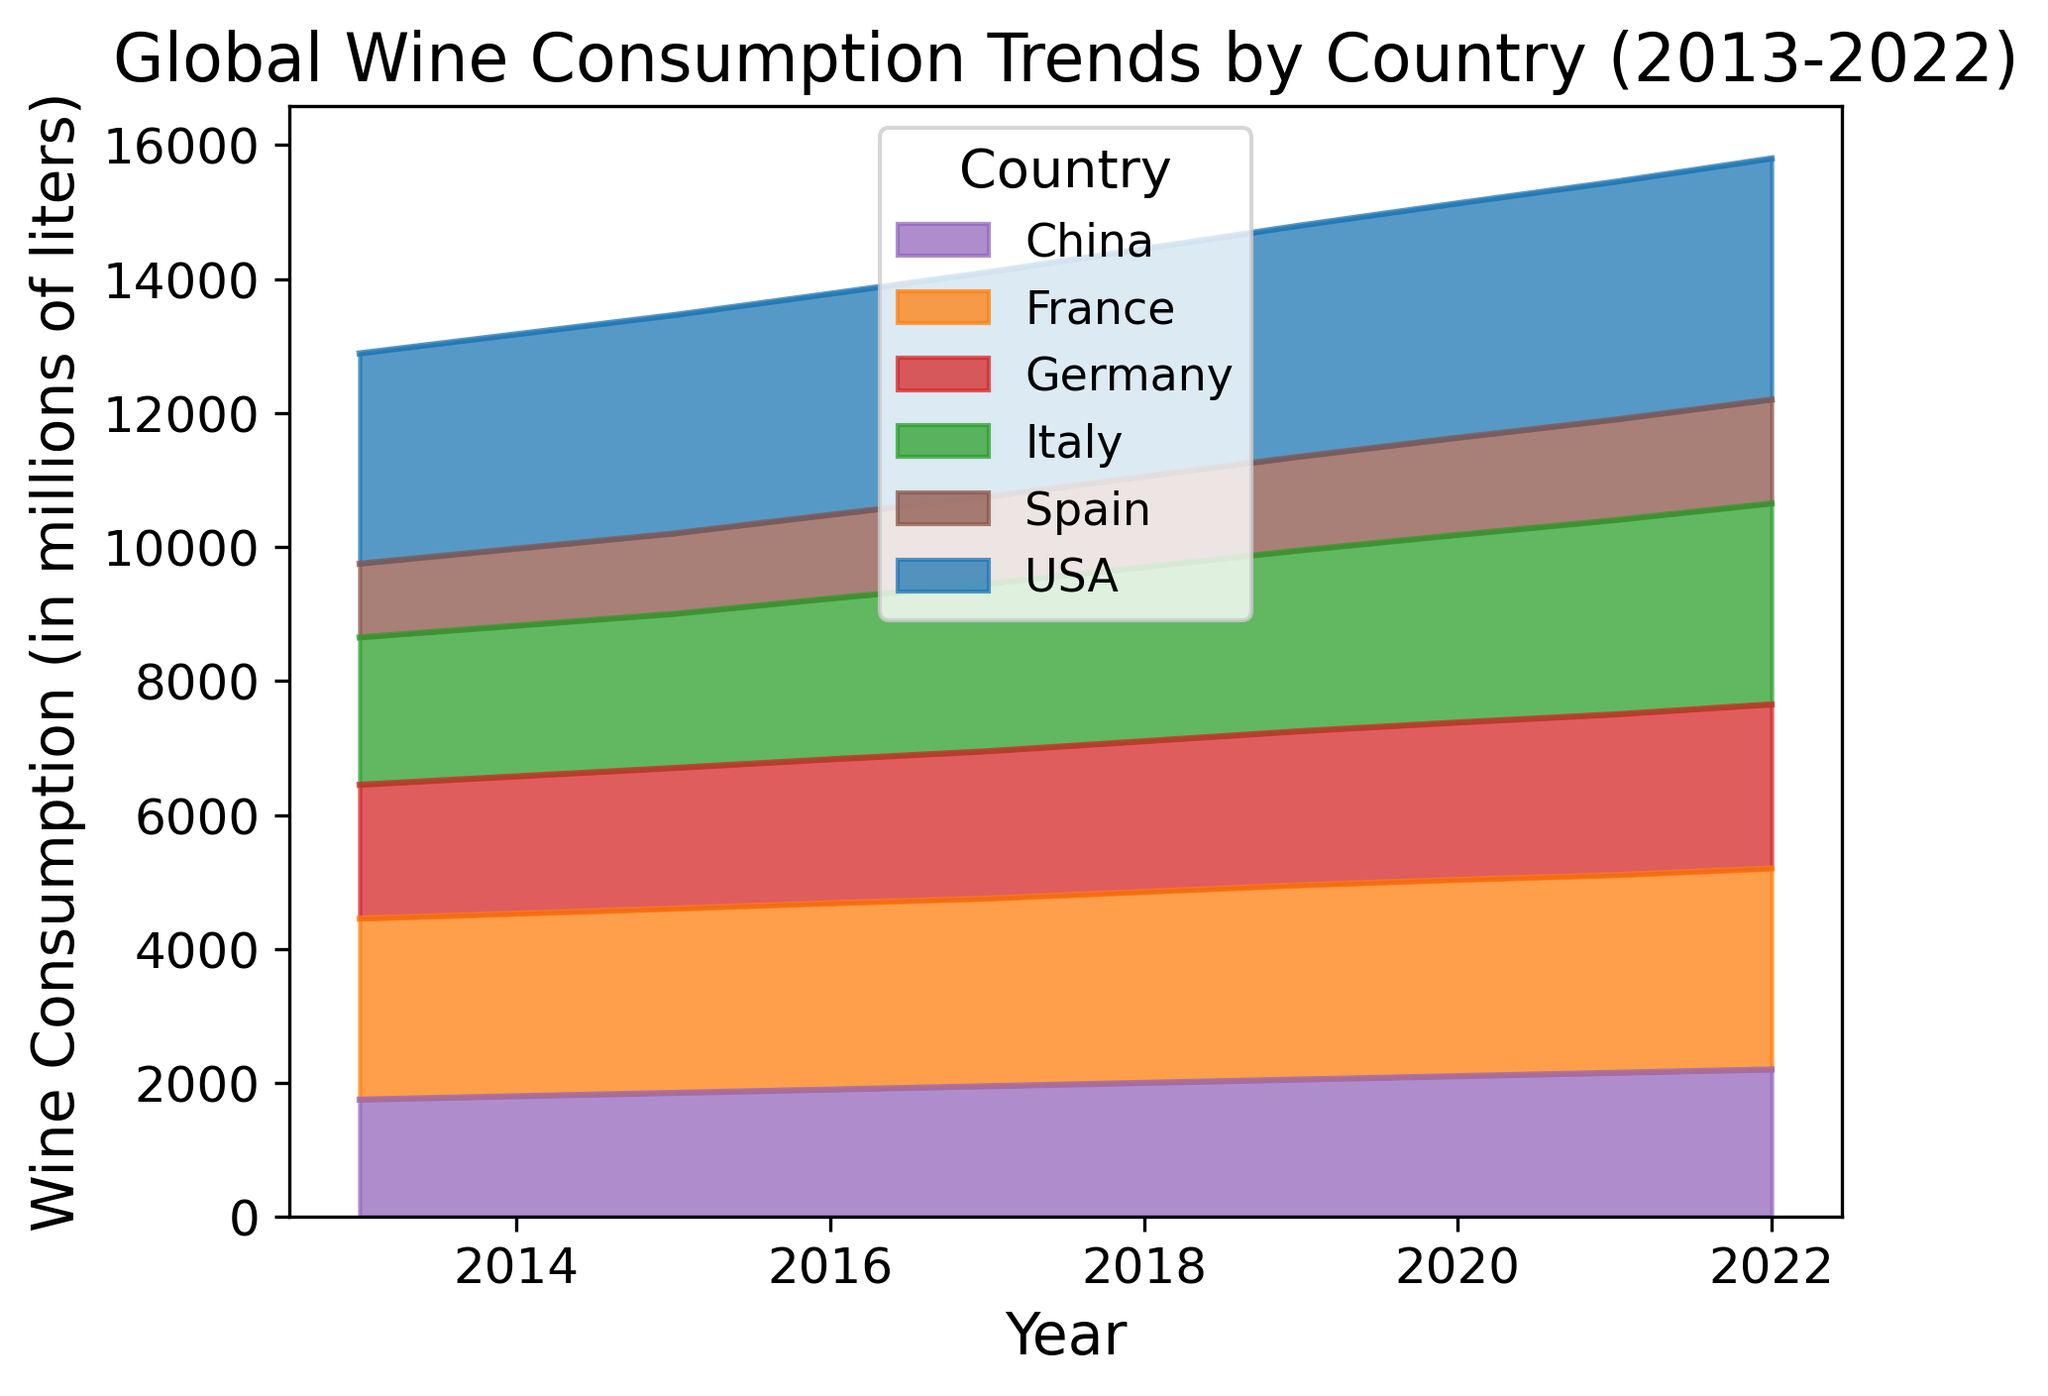How did France's wine consumption change from 2013 to 2022? France's wine consumption in 2013 was 2700 million liters, and it increased to 3000 million liters in 2022. This shows an increase over the decade.
Answer: Increased from 2700 to 3000 million liters Which country had the highest wine consumption in 2022? By observing the height of the areas in the 2022 section, it is evident that the USA had the highest wine consumption in 2022.
Answer: USA Between Germany and China, which country had a higher growth in wine consumption from 2013 to 2022? Germany's consumption grew from 2000 million liters in 2013 to 2450 million liters in 2022, which is a growth of 450 million liters. China's consumption grew from 1750 million liters in 2013 to 2200 million liters in 2022, which is a growth of 450 million liters.
Answer: Both countries had the same growth of 450 million liters How does the overall wine consumption trend from 2013 to 2022 compare between Italy and Spain? Italy's consumption increased from 2200 to 3000 million liters, while Spain's consumption increased from 1100 to 1550 million liters. Italy had a larger increase in wine consumption compared to Spain over the decade.
Answer: Italy had a larger increase Which country had the smallest increase in wine consumption over the decade? By examining the change in the area from 2013 to 2022 for each country, it appears that Spain had the smallest increase, growing from 1100 to 1550 million liters (an increase of 450 million liters).
Answer: Spain In which year did the USA's wine consumption surpass 3500 million liters? The USA's consumption passed the 3500 million liters mark in 2020, where it was recorded at 3500 million liters.
Answer: 2020 By looking at the visual heights, which country’s consumption plateaued the most over the decade? France's wine consumption shows the least steep increase and more of a plateau from 2013 to 2022 relative to other countries. The increase is much slower and steadier compared to others.
Answer: France Among the listed countries, which had the highest growth rate in their wine consumption from 2013 to 2022? Italy shows the highest growth rate, increasing from 2200 million liters to 3000 million liters, which is a growth rate of approximately 36.4%.
Answer: Italy 